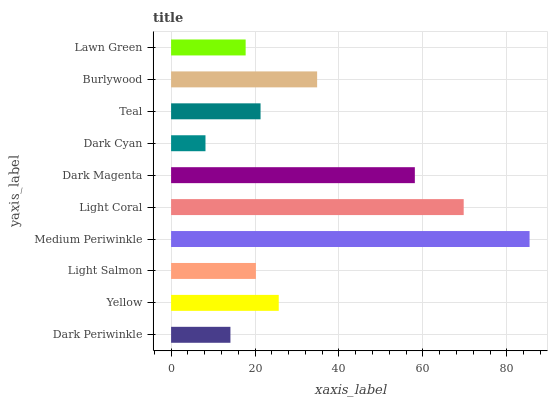Is Dark Cyan the minimum?
Answer yes or no. Yes. Is Medium Periwinkle the maximum?
Answer yes or no. Yes. Is Yellow the minimum?
Answer yes or no. No. Is Yellow the maximum?
Answer yes or no. No. Is Yellow greater than Dark Periwinkle?
Answer yes or no. Yes. Is Dark Periwinkle less than Yellow?
Answer yes or no. Yes. Is Dark Periwinkle greater than Yellow?
Answer yes or no. No. Is Yellow less than Dark Periwinkle?
Answer yes or no. No. Is Yellow the high median?
Answer yes or no. Yes. Is Teal the low median?
Answer yes or no. Yes. Is Light Salmon the high median?
Answer yes or no. No. Is Dark Cyan the low median?
Answer yes or no. No. 